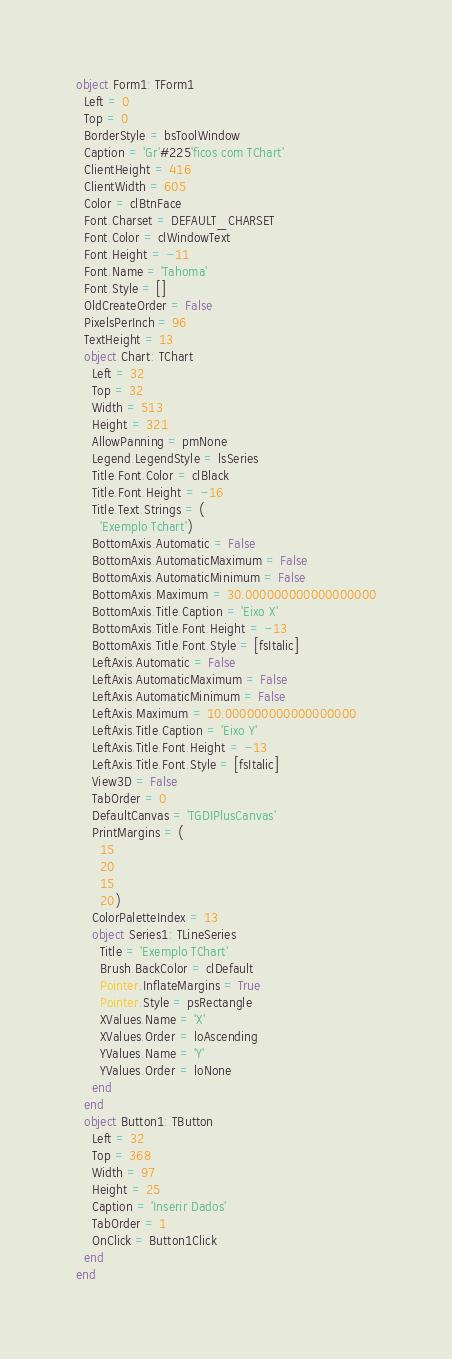Convert code to text. <code><loc_0><loc_0><loc_500><loc_500><_Pascal_>object Form1: TForm1
  Left = 0
  Top = 0
  BorderStyle = bsToolWindow
  Caption = 'Gr'#225'ficos com TChart'
  ClientHeight = 416
  ClientWidth = 605
  Color = clBtnFace
  Font.Charset = DEFAULT_CHARSET
  Font.Color = clWindowText
  Font.Height = -11
  Font.Name = 'Tahoma'
  Font.Style = []
  OldCreateOrder = False
  PixelsPerInch = 96
  TextHeight = 13
  object Chart: TChart
    Left = 32
    Top = 32
    Width = 513
    Height = 321
    AllowPanning = pmNone
    Legend.LegendStyle = lsSeries
    Title.Font.Color = clBlack
    Title.Font.Height = -16
    Title.Text.Strings = (
      'Exemplo Tchart')
    BottomAxis.Automatic = False
    BottomAxis.AutomaticMaximum = False
    BottomAxis.AutomaticMinimum = False
    BottomAxis.Maximum = 30.000000000000000000
    BottomAxis.Title.Caption = 'Eixo X'
    BottomAxis.Title.Font.Height = -13
    BottomAxis.Title.Font.Style = [fsItalic]
    LeftAxis.Automatic = False
    LeftAxis.AutomaticMaximum = False
    LeftAxis.AutomaticMinimum = False
    LeftAxis.Maximum = 10.000000000000000000
    LeftAxis.Title.Caption = 'Eixo Y'
    LeftAxis.Title.Font.Height = -13
    LeftAxis.Title.Font.Style = [fsItalic]
    View3D = False
    TabOrder = 0
    DefaultCanvas = 'TGDIPlusCanvas'
    PrintMargins = (
      15
      20
      15
      20)
    ColorPaletteIndex = 13
    object Series1: TLineSeries
      Title = 'Exemplo TChart'
      Brush.BackColor = clDefault
      Pointer.InflateMargins = True
      Pointer.Style = psRectangle
      XValues.Name = 'X'
      XValues.Order = loAscending
      YValues.Name = 'Y'
      YValues.Order = loNone
    end
  end
  object Button1: TButton
    Left = 32
    Top = 368
    Width = 97
    Height = 25
    Caption = 'Inserir Dados'
    TabOrder = 1
    OnClick = Button1Click
  end
end
</code> 